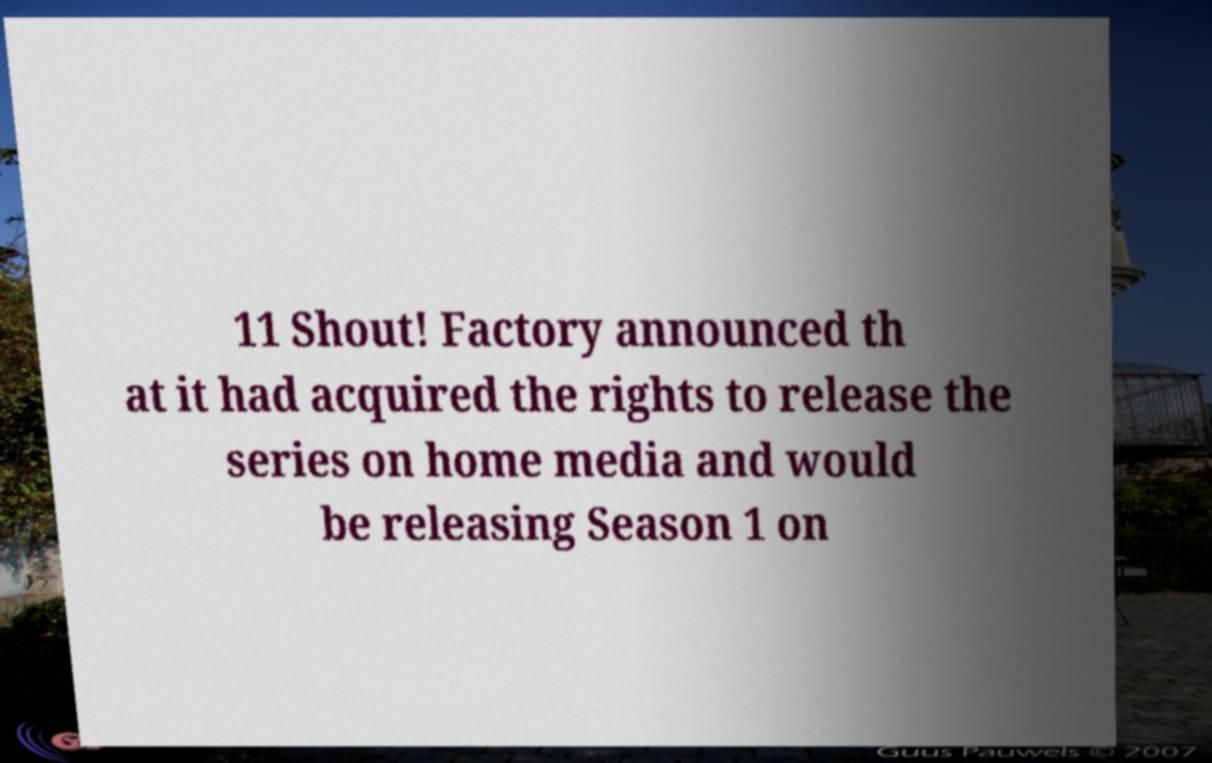Can you accurately transcribe the text from the provided image for me? 11 Shout! Factory announced th at it had acquired the rights to release the series on home media and would be releasing Season 1 on 